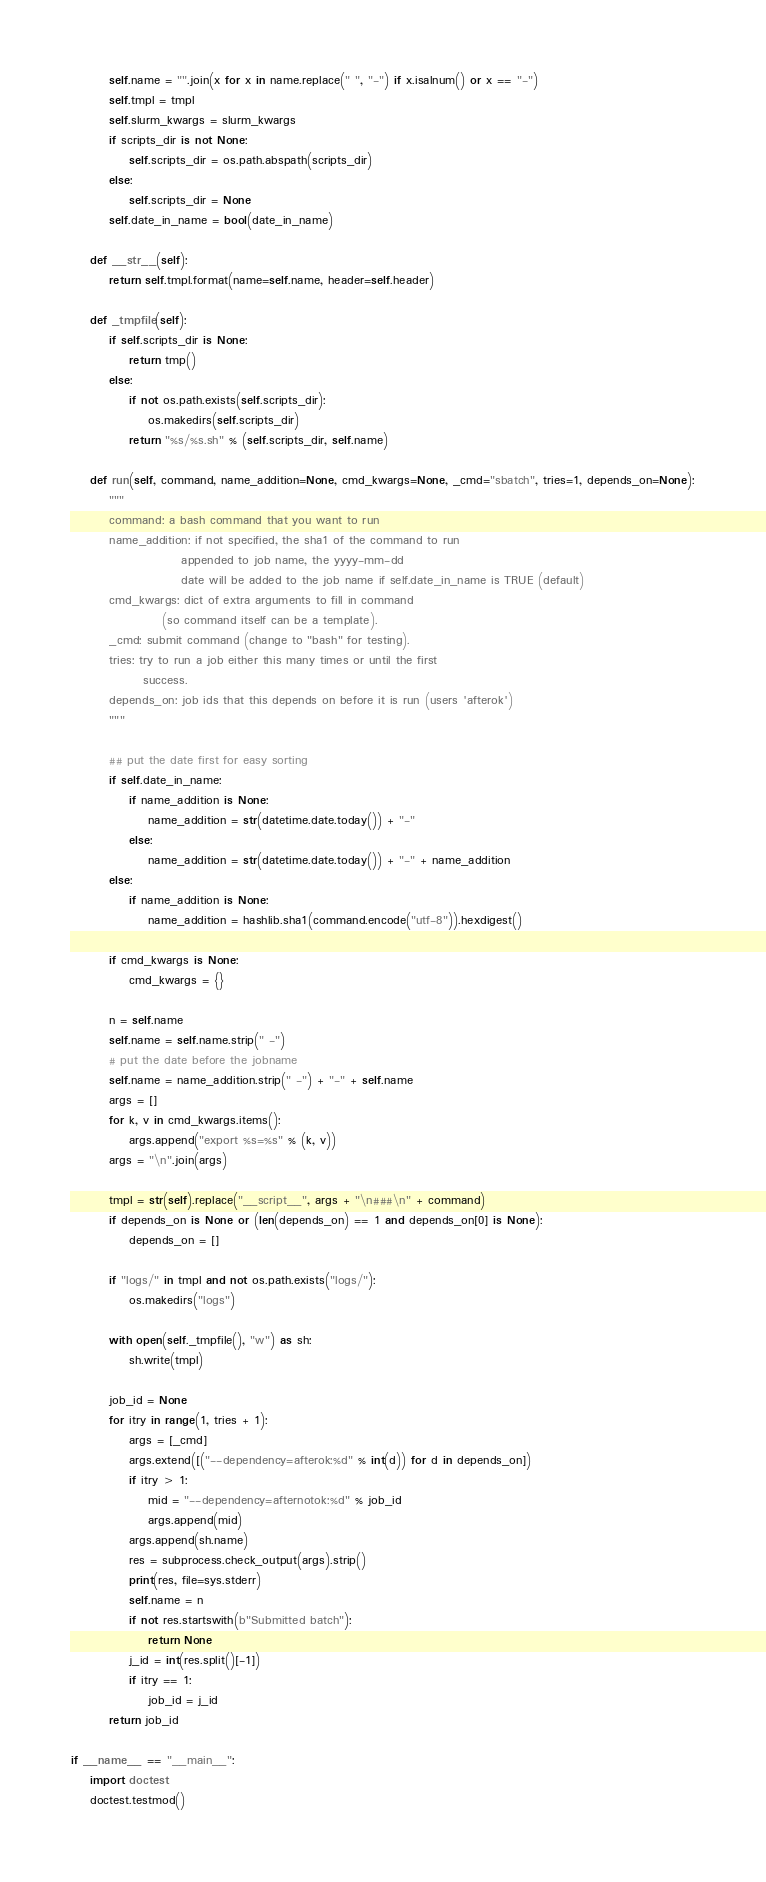<code> <loc_0><loc_0><loc_500><loc_500><_Python_>        self.name = "".join(x for x in name.replace(" ", "-") if x.isalnum() or x == "-")
        self.tmpl = tmpl
        self.slurm_kwargs = slurm_kwargs
        if scripts_dir is not None:
            self.scripts_dir = os.path.abspath(scripts_dir)
        else:
            self.scripts_dir = None
        self.date_in_name = bool(date_in_name)

    def __str__(self):
        return self.tmpl.format(name=self.name, header=self.header)

    def _tmpfile(self):
        if self.scripts_dir is None:
            return tmp()
        else:
            if not os.path.exists(self.scripts_dir):
                os.makedirs(self.scripts_dir)
            return "%s/%s.sh" % (self.scripts_dir, self.name)

    def run(self, command, name_addition=None, cmd_kwargs=None, _cmd="sbatch", tries=1, depends_on=None):
        """
        command: a bash command that you want to run
        name_addition: if not specified, the sha1 of the command to run
                       appended to job name, the yyyy-mm-dd
                       date will be added to the job name if self.date_in_name is TRUE (default)
        cmd_kwargs: dict of extra arguments to fill in command
                   (so command itself can be a template).
        _cmd: submit command (change to "bash" for testing).
        tries: try to run a job either this many times or until the first
               success.
        depends_on: job ids that this depends on before it is run (users 'afterok')
        """

        ## put the date first for easy sorting
        if self.date_in_name:
            if name_addition is None:
                name_addition = str(datetime.date.today()) + "-"
            else:
                name_addition = str(datetime.date.today()) + "-" + name_addition
        else:
            if name_addition is None:
                name_addition = hashlib.sha1(command.encode("utf-8")).hexdigest()

        if cmd_kwargs is None:
            cmd_kwargs = {}

        n = self.name
        self.name = self.name.strip(" -")
        # put the date before the jobname
        self.name = name_addition.strip(" -") + "-" + self.name
        args = []
        for k, v in cmd_kwargs.items():
            args.append("export %s=%s" % (k, v))
        args = "\n".join(args)

        tmpl = str(self).replace("__script__", args + "\n###\n" + command)
        if depends_on is None or (len(depends_on) == 1 and depends_on[0] is None):
            depends_on = []

        if "logs/" in tmpl and not os.path.exists("logs/"):
            os.makedirs("logs")

        with open(self._tmpfile(), "w") as sh:
            sh.write(tmpl)

        job_id = None
        for itry in range(1, tries + 1):
            args = [_cmd]
            args.extend([("--dependency=afterok:%d" % int(d)) for d in depends_on])
            if itry > 1:
                mid = "--dependency=afternotok:%d" % job_id
                args.append(mid)
            args.append(sh.name)
            res = subprocess.check_output(args).strip()
            print(res, file=sys.stderr)
            self.name = n
            if not res.startswith(b"Submitted batch"):
                return None
            j_id = int(res.split()[-1])
            if itry == 1:
                job_id = j_id
        return job_id

if __name__ == "__main__":
    import doctest
    doctest.testmod()
</code> 